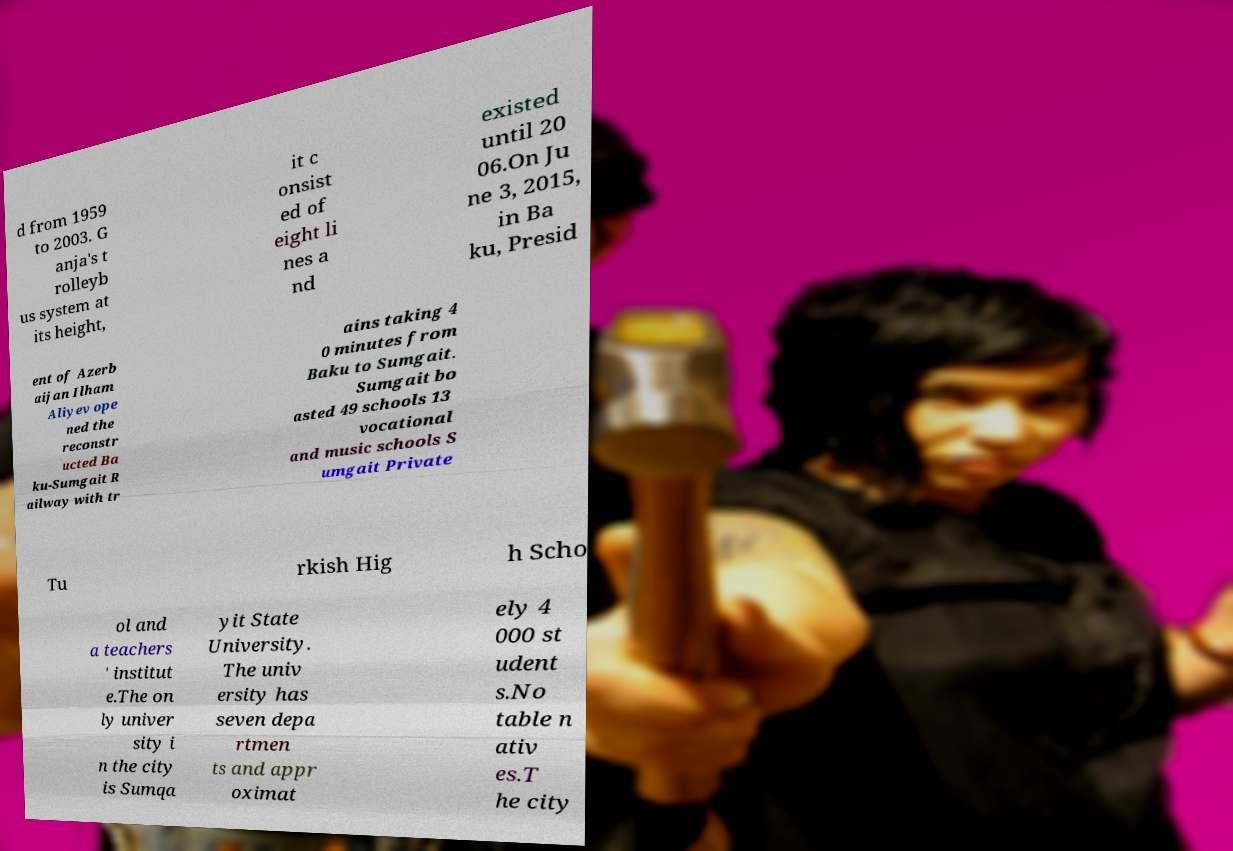Could you extract and type out the text from this image? d from 1959 to 2003. G anja's t rolleyb us system at its height, it c onsist ed of eight li nes a nd existed until 20 06.On Ju ne 3, 2015, in Ba ku, Presid ent of Azerb aijan Ilham Aliyev ope ned the reconstr ucted Ba ku-Sumgait R ailway with tr ains taking 4 0 minutes from Baku to Sumgait. Sumgait bo asted 49 schools 13 vocational and music schools S umgait Private Tu rkish Hig h Scho ol and a teachers ' institut e.The on ly univer sity i n the city is Sumqa yit State University. The univ ersity has seven depa rtmen ts and appr oximat ely 4 000 st udent s.No table n ativ es.T he city 